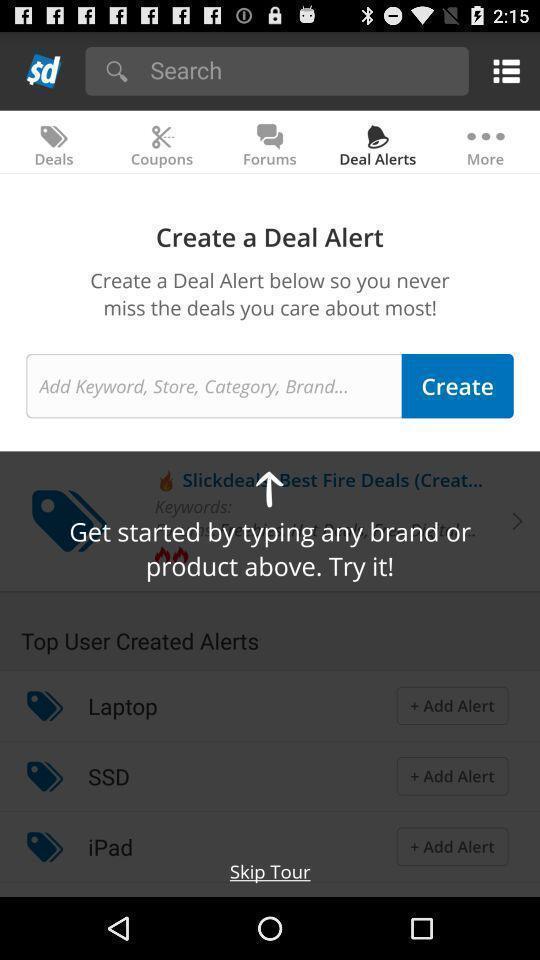Provide a textual representation of this image. Pop-up showing an option to create the alert. 